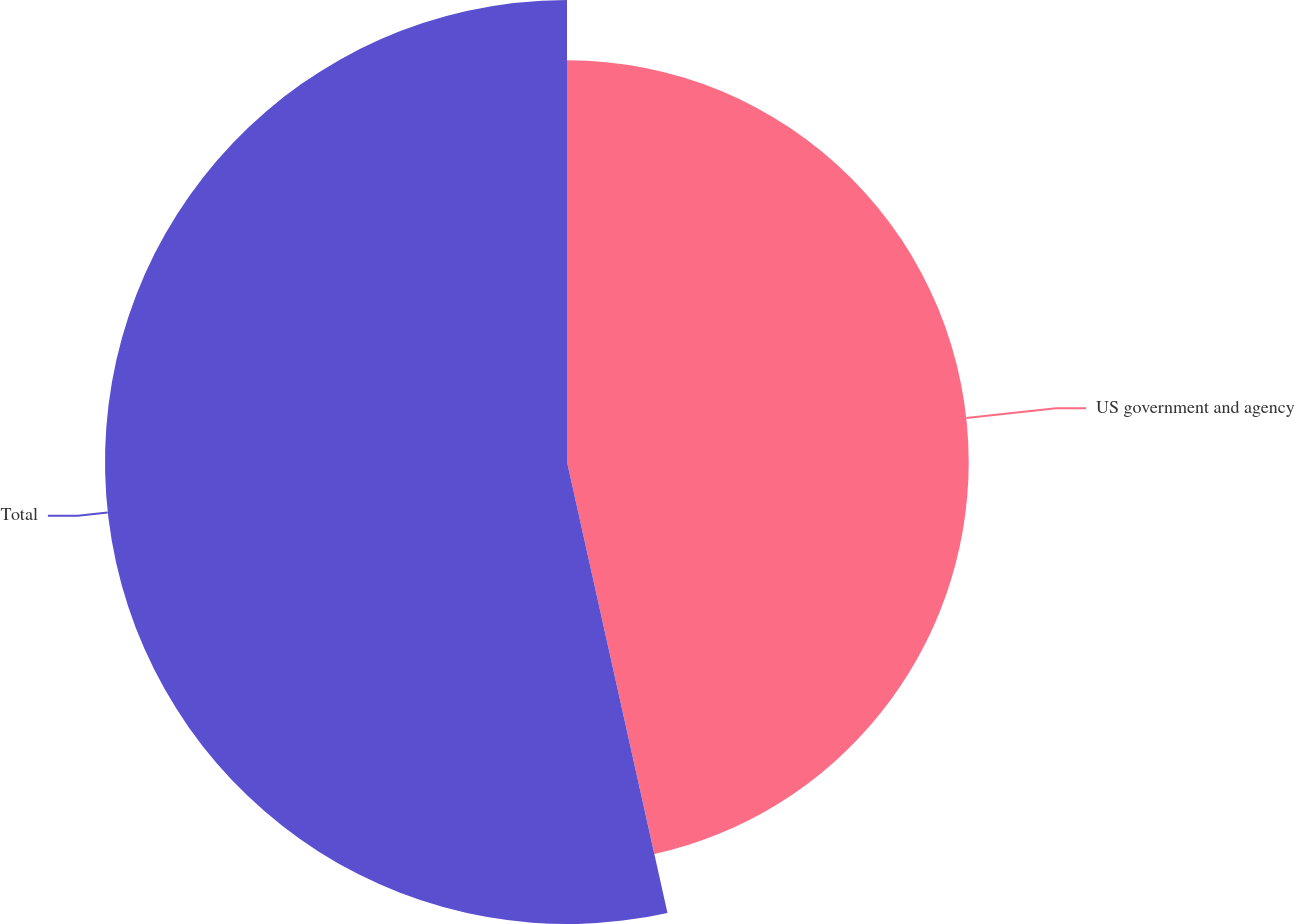Convert chart to OTSL. <chart><loc_0><loc_0><loc_500><loc_500><pie_chart><fcel>US government and agency<fcel>Total<nl><fcel>46.51%<fcel>53.49%<nl></chart> 